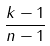<formula> <loc_0><loc_0><loc_500><loc_500>\frac { k - 1 } { n - 1 }</formula> 